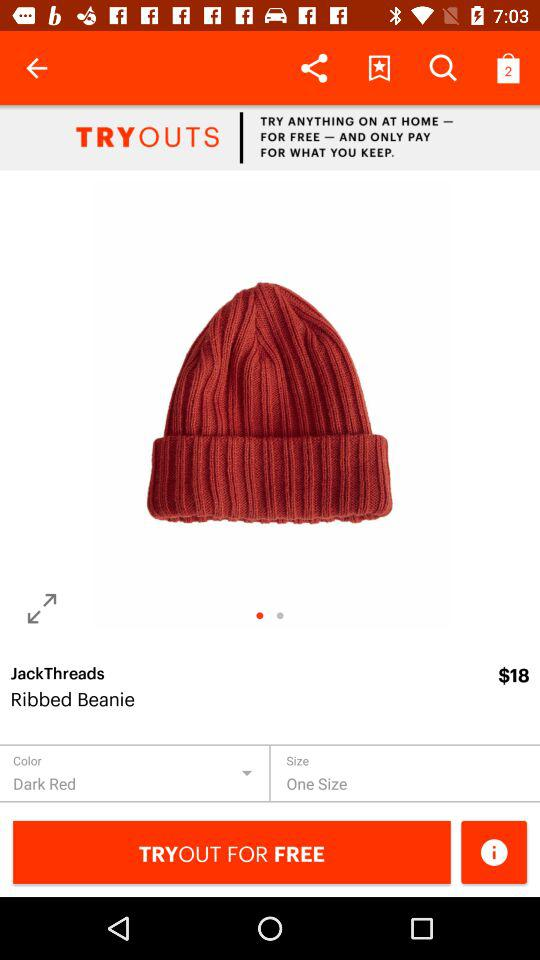How much is the product if I buy it now?
Answer the question using a single word or phrase. $18 